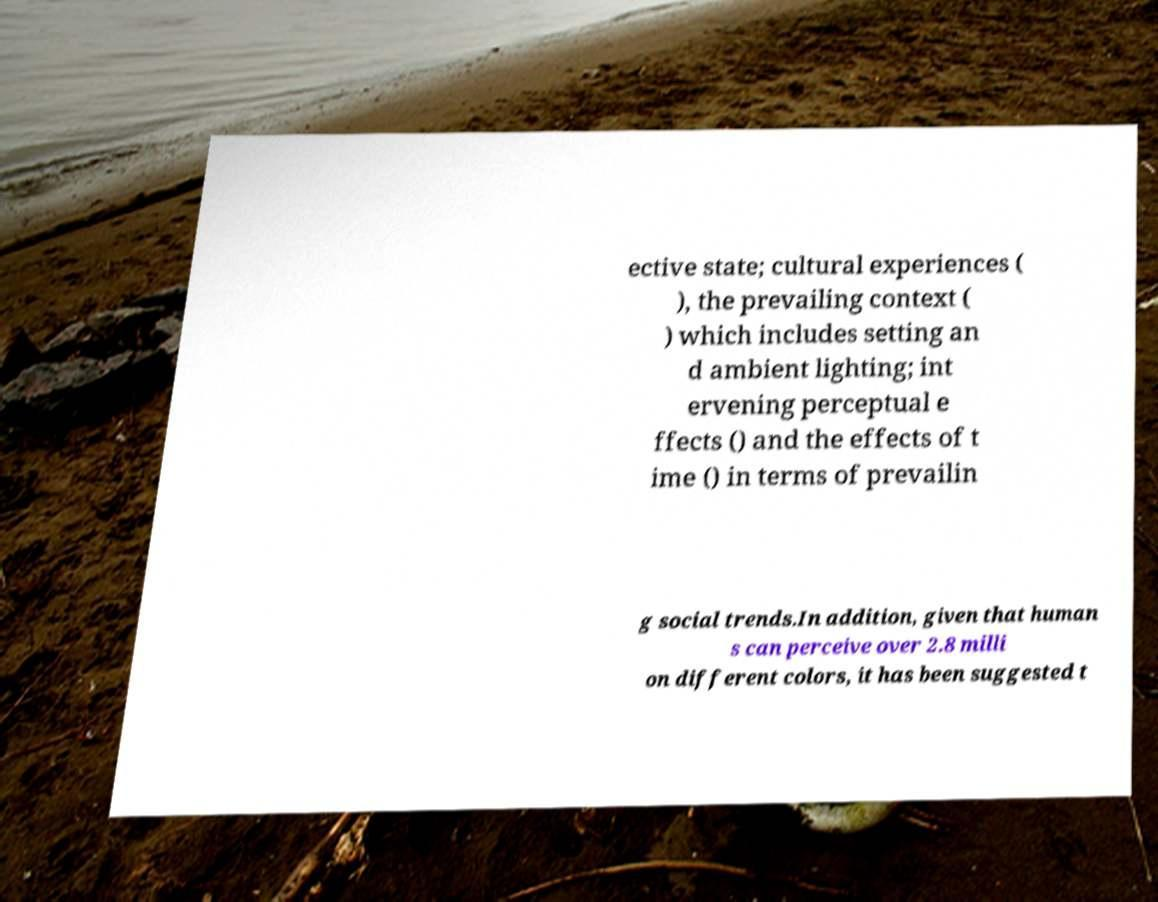For documentation purposes, I need the text within this image transcribed. Could you provide that? ective state; cultural experiences ( ), the prevailing context ( ) which includes setting an d ambient lighting; int ervening perceptual e ffects () and the effects of t ime () in terms of prevailin g social trends.In addition, given that human s can perceive over 2.8 milli on different colors, it has been suggested t 